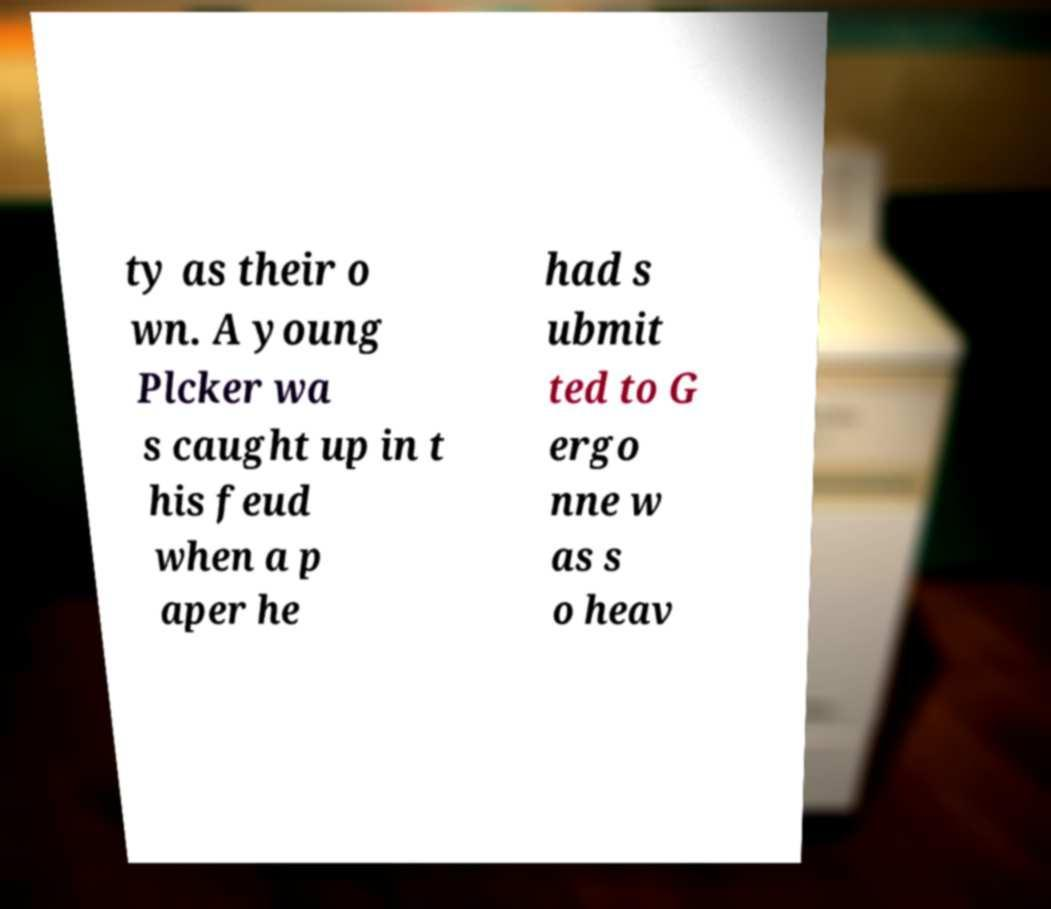Can you read and provide the text displayed in the image?This photo seems to have some interesting text. Can you extract and type it out for me? ty as their o wn. A young Plcker wa s caught up in t his feud when a p aper he had s ubmit ted to G ergo nne w as s o heav 